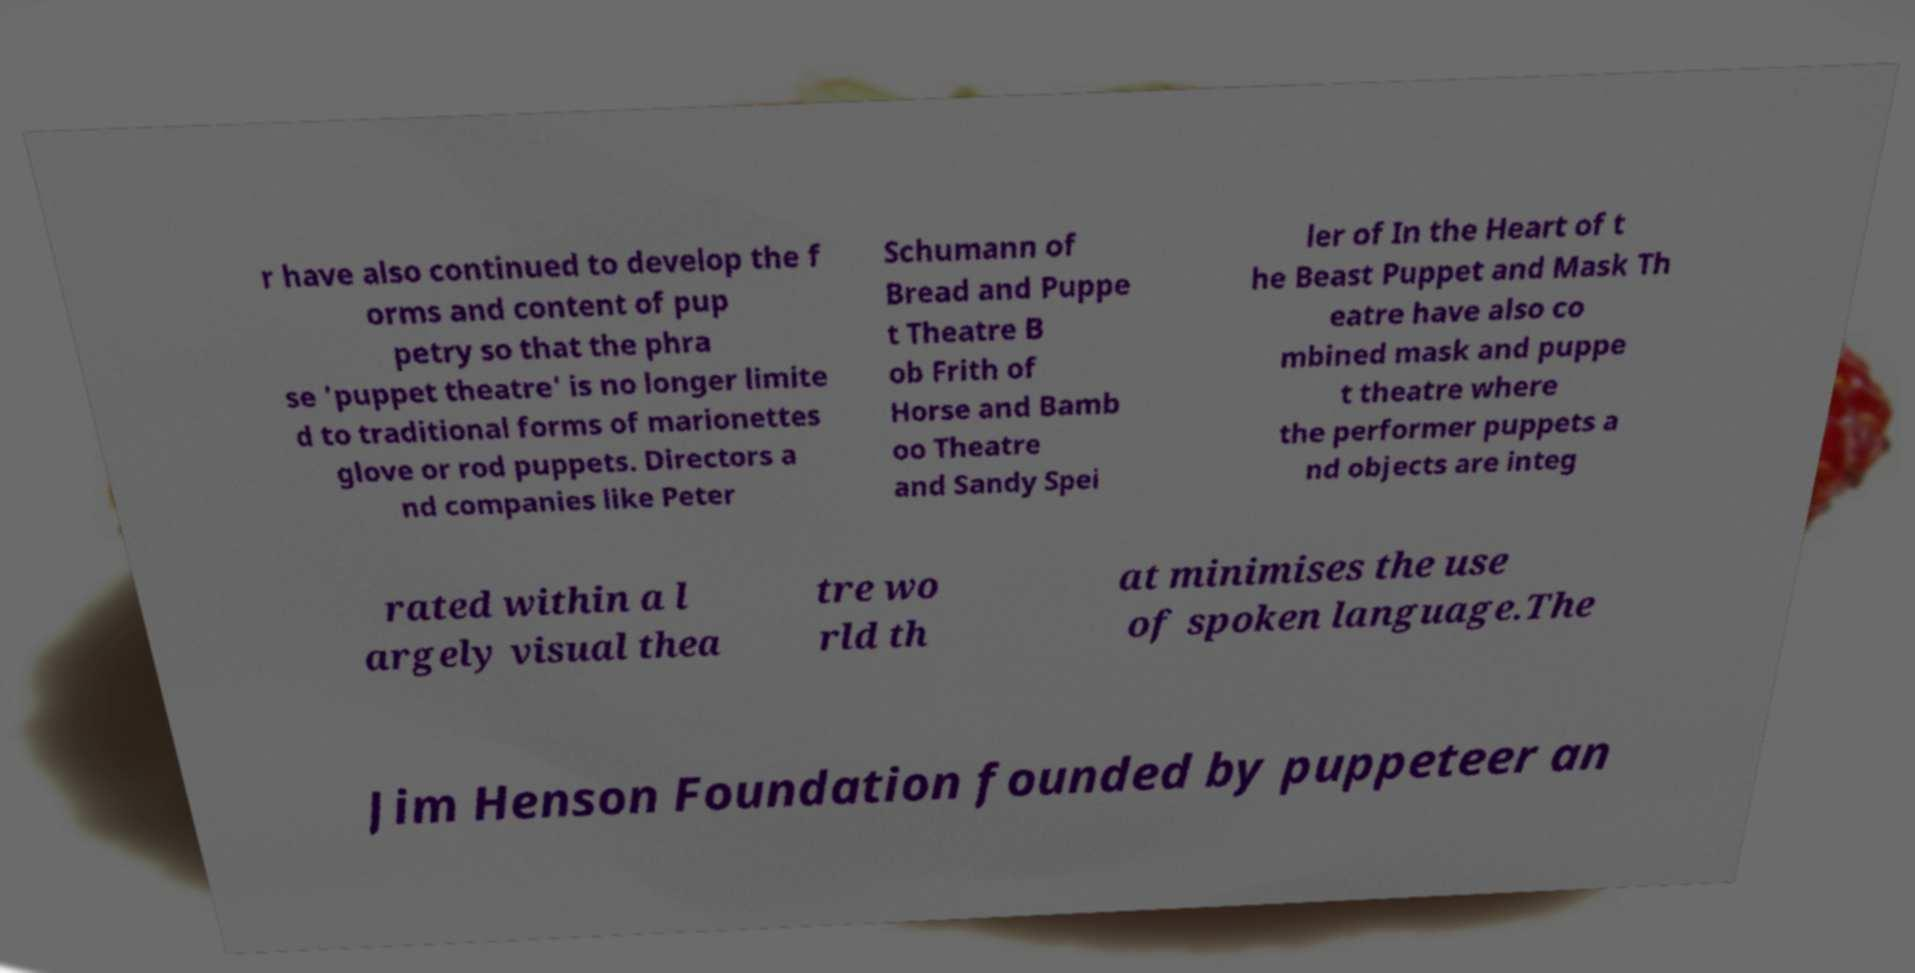Please read and relay the text visible in this image. What does it say? r have also continued to develop the f orms and content of pup petry so that the phra se 'puppet theatre' is no longer limite d to traditional forms of marionettes glove or rod puppets. Directors a nd companies like Peter Schumann of Bread and Puppe t Theatre B ob Frith of Horse and Bamb oo Theatre and Sandy Spei ler of In the Heart of t he Beast Puppet and Mask Th eatre have also co mbined mask and puppe t theatre where the performer puppets a nd objects are integ rated within a l argely visual thea tre wo rld th at minimises the use of spoken language.The Jim Henson Foundation founded by puppeteer an 